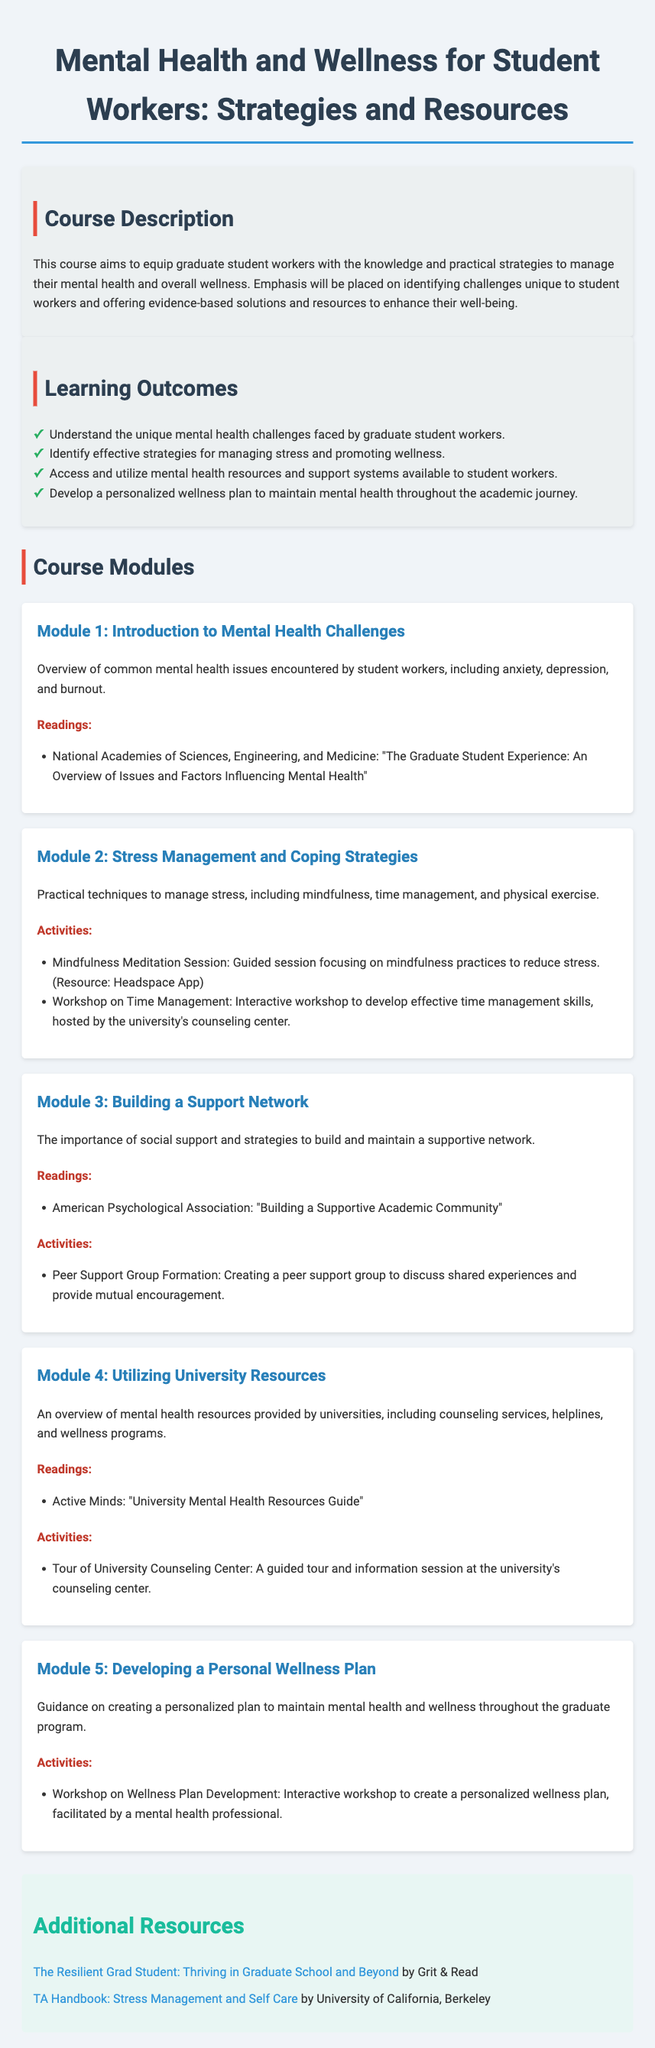What is the course title? The course title is mentioned at the beginning of the document as the main heading.
Answer: Mental Health and Wellness for Student Workers: Strategies and Resources What is the main goal of the course? The main goal is stated in the course description section and encapsulates the intent of the course.
Answer: Equip graduate student workers with the knowledge and practical strategies to manage their mental health and overall wellness How many learning outcomes are listed? The document includes a list of outcomes in the learning outcomes section.
Answer: Four What module discusses stress management? The title of the module that focuses on stress management can be found in the course modules section.
Answer: Module 2: Stress Management and Coping Strategies Which platform is suggested for mindfulness meditation? A specific resource mentioned in the activities section provides a platform for mindfulness meditation.
Answer: Headspace App What organization provides the guide on university mental health resources? The reading list in Module 4 includes an organization that offers a mental health resources guide.
Answer: Active Minds Which activity involves creating a personalized wellness plan? The specific workshop related to this activity is detailed in the last module.
Answer: Workshop on Wellness Plan Development What theme does Module 3 emphasize? The focus of Module 3 is indicated in the module title and description.
Answer: Building a Support Network How many modules are in the course? The number of distinct sections labeled as modules can be counted in the Course Modules section.
Answer: Five 